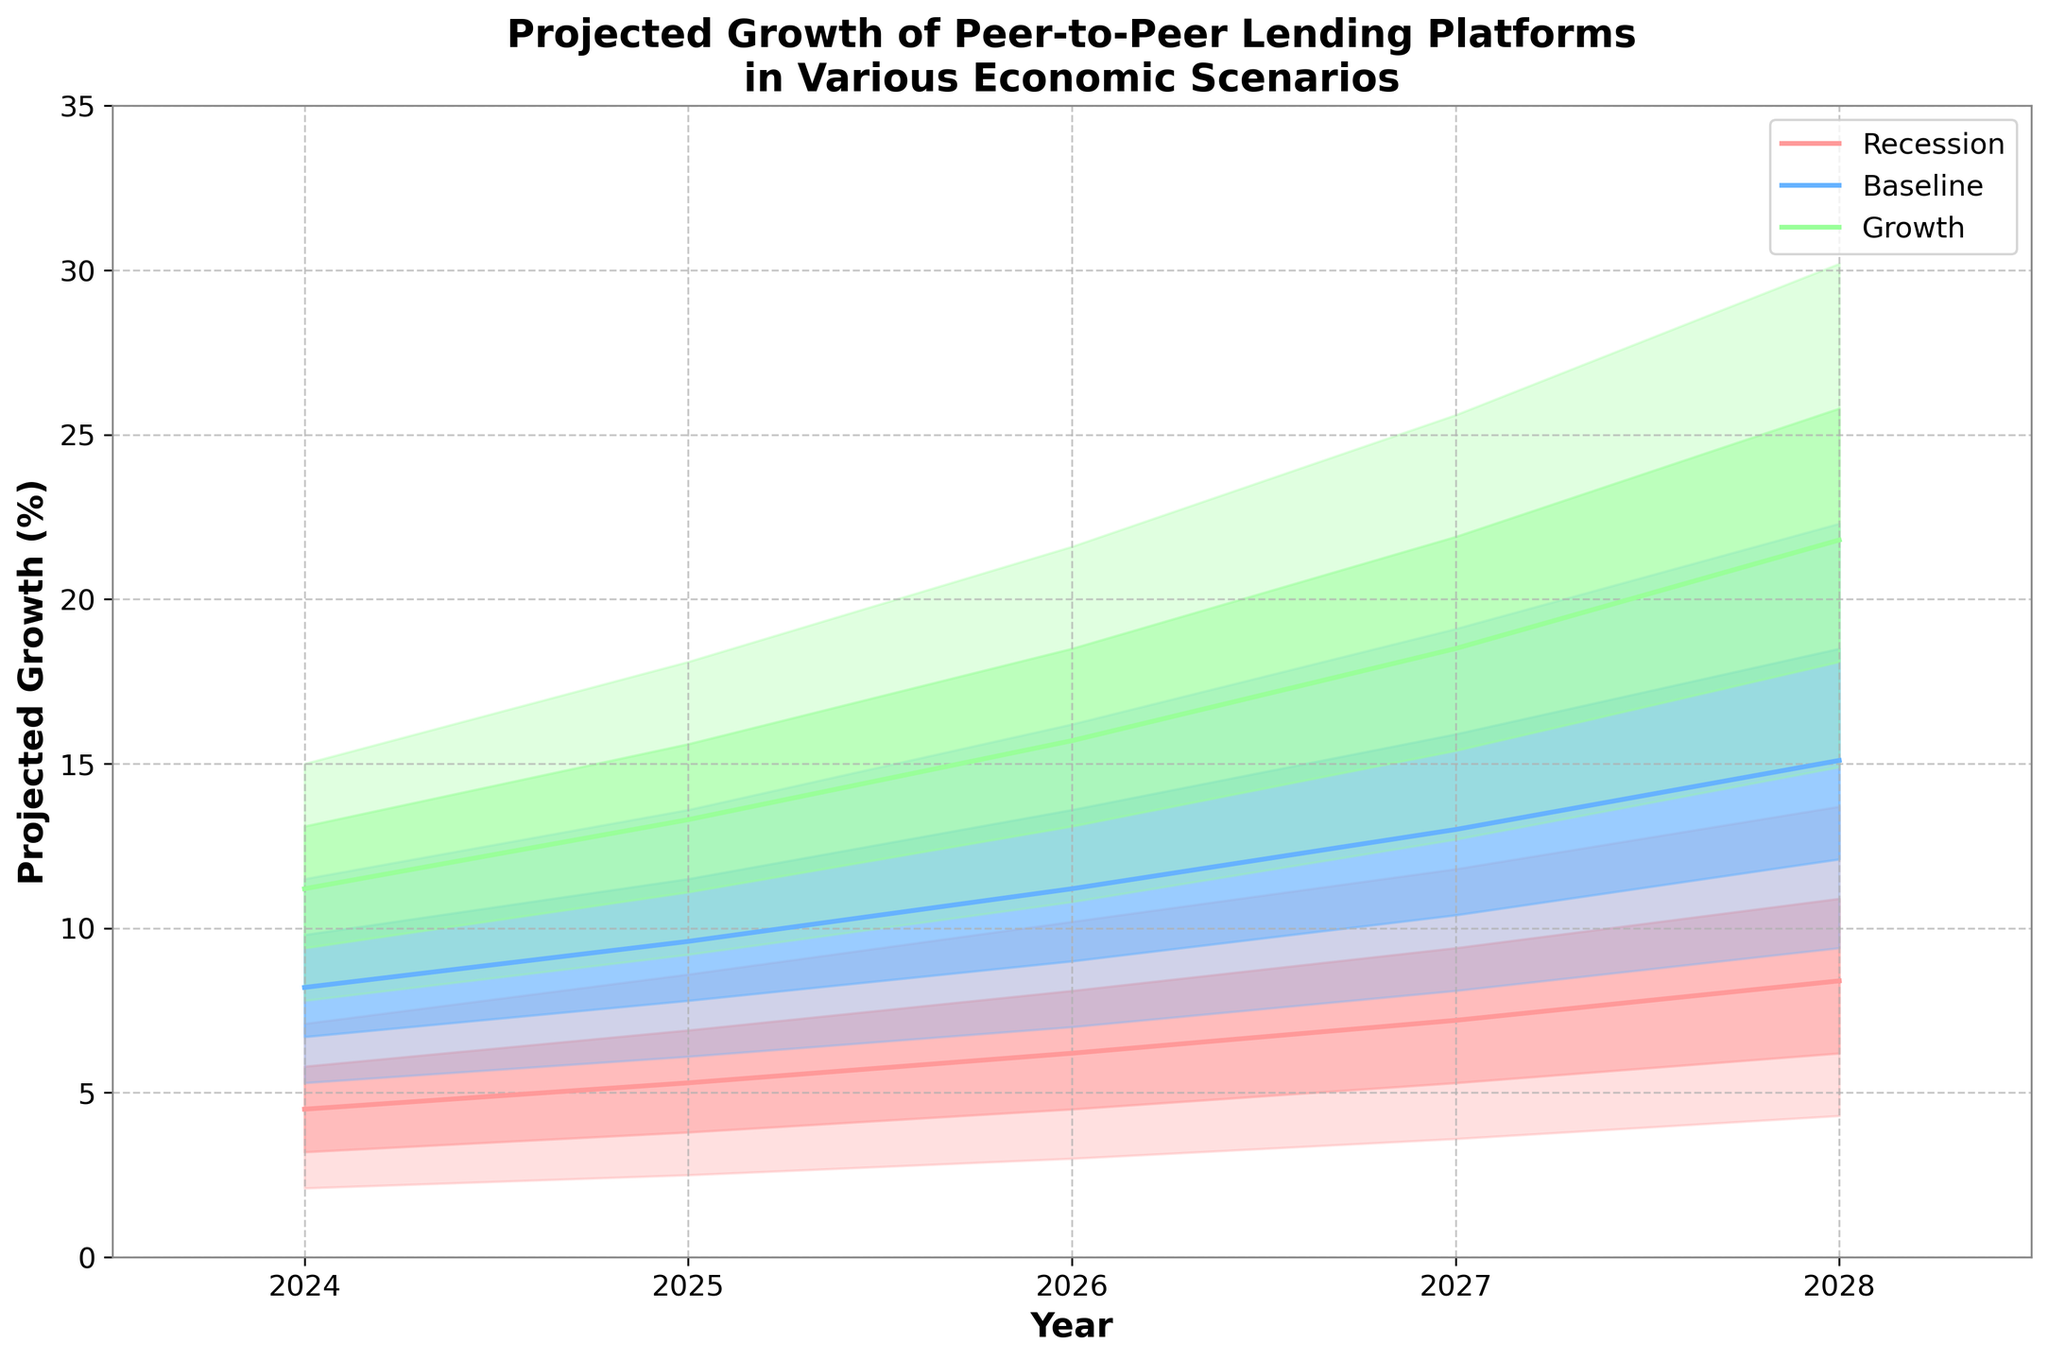What is the title of the figure? The title is generally located at the top of the figure. It provides a brief description of the figure.
Answer: Projected Growth of Peer-to-Peer Lending Platforms in Various Economic Scenarios How many years are displayed in the figure? The years are represented on the x-axis. We need to count the distinct years presented.
Answer: 5 What is the maximum projected growth percentage in 2026 under the Growth scenario? We need to locate the Growth scenario for the year 2026 and look at the maximum value in the shaded region.
Answer: 21.6% In which year is the median growth highest under the Baseline scenario? The median growth is shown by the middle line in each scenario's fan. We need to compare the median growth values across the years within the Baseline scenario.
Answer: 2028 What is the difference between the high and low projections for the year 2025 under the Recession scenario? To find this, subtract the low projection value from the high projection value for 2025 under the Recession scenario.
Answer: 6.1% How do the mid values in 2027 compare between the Recession and Baseline scenarios? Locate the mid values for 2027 for both scenarios and compare them.
Answer: Baseline is higher What is the total range covered by the shaded region for the year 2024 in the Growth scenario? Determine the range by subtracting the minimum value (low) from the maximum value (high) for the Growth scenario in 2024.
Answer: 7.2% Which scenario shows the largest increase in median growth between 2024 and 2028? Calculate the difference in median growth between 2024 and 2028 for each scenario, then identify which one has the greatest increase.
Answer: Growth What is the projected growth under the Growth scenario in 2028 for the mid-high percentile? Look for the mid-high value in the Growth scenario for the year 2028.
Answer: 25.8% Compare the spread of projected growth in 2024 between the Recession and Baseline scenarios. The spread is determined by the difference between high and low values. Compare these spreads for both scenarios in 2024.
Answer: Baseline has a larger spread 